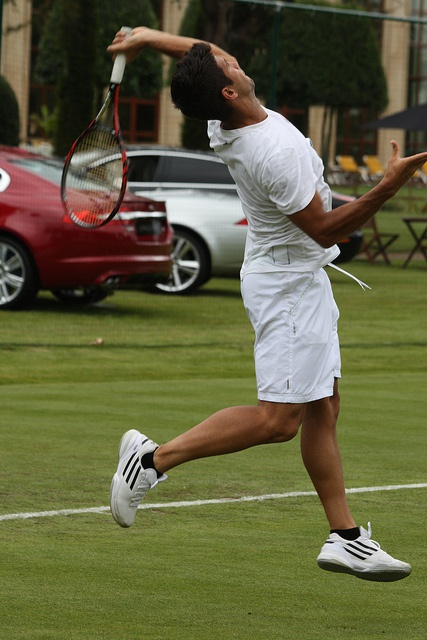Describe the objects in this image and their specific colors. I can see people in black, lightgray, darkgray, and olive tones, car in black, maroon, brown, and gray tones, car in black, darkgray, gray, and lightgray tones, tennis racket in black, gray, darkgray, and brown tones, and umbrella in black and gray tones in this image. 